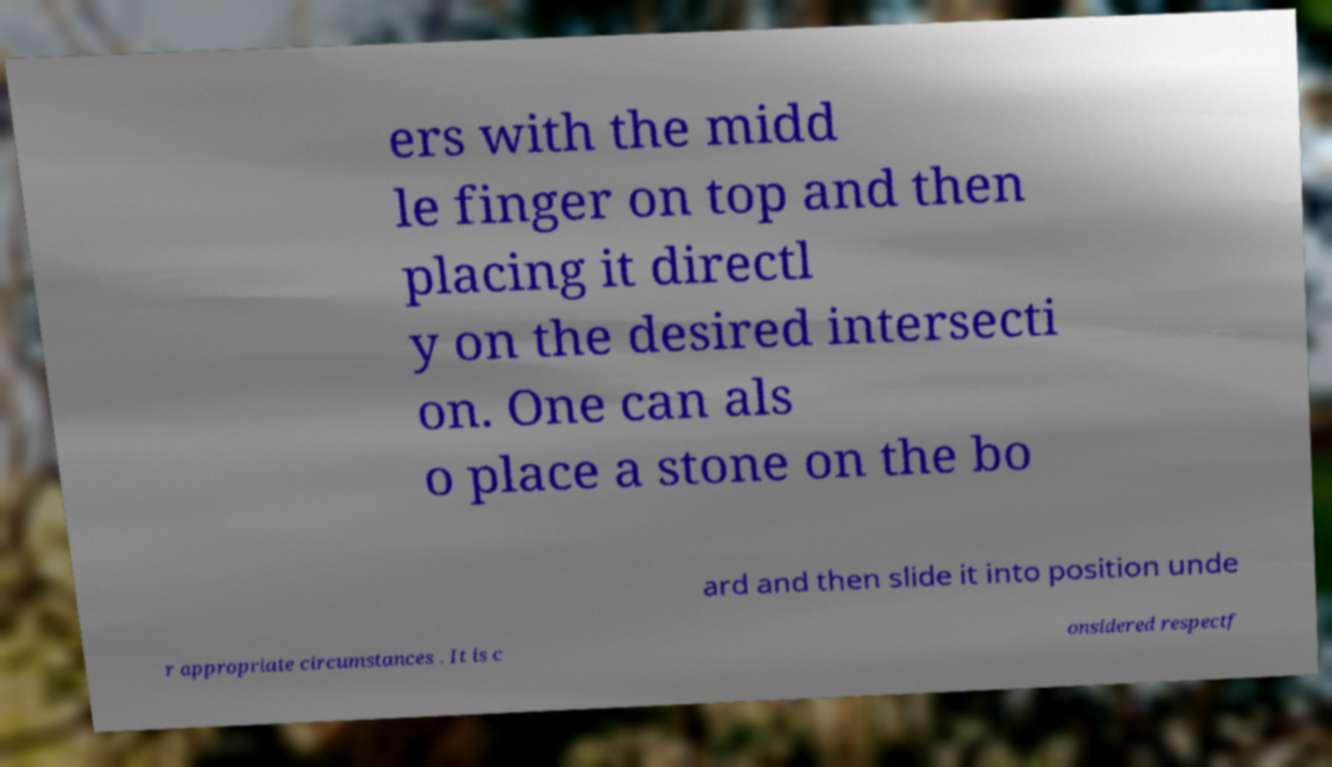Could you extract and type out the text from this image? ers with the midd le finger on top and then placing it directl y on the desired intersecti on. One can als o place a stone on the bo ard and then slide it into position unde r appropriate circumstances . It is c onsidered respectf 